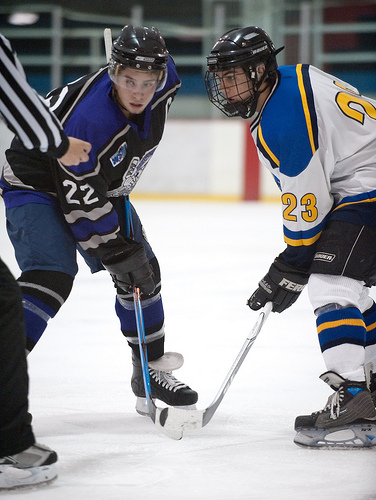<image>
Is there a man to the right of the hockey stick? Yes. From this viewpoint, the man is positioned to the right side relative to the hockey stick. 